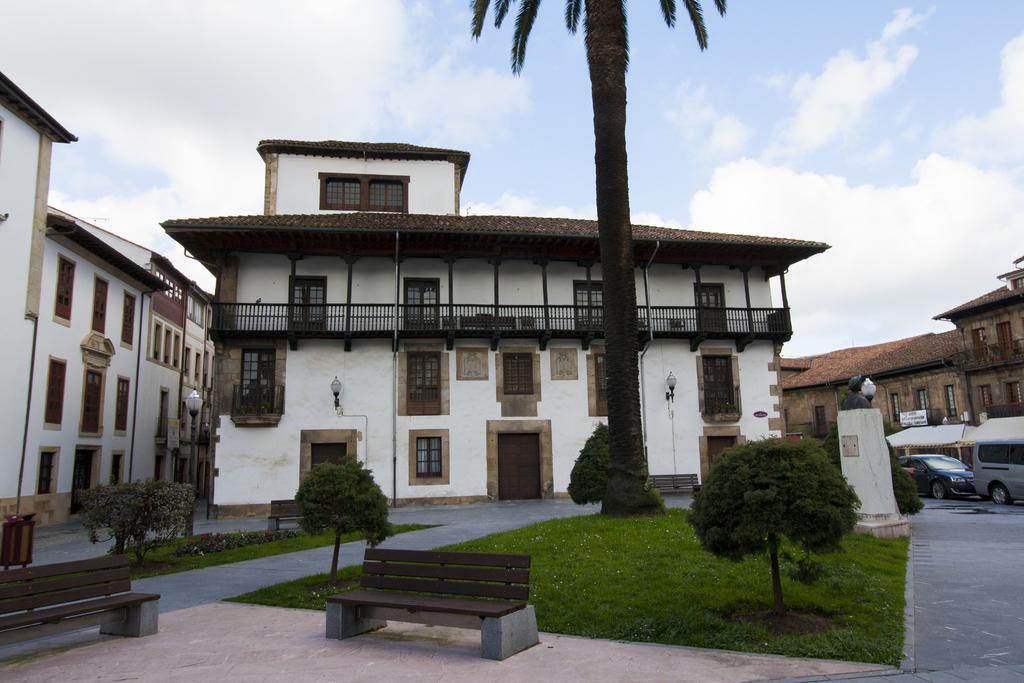How would you summarize this image in a sentence or two? At the top we can see sky with clouds. These are buildings. This is a door and window. Here we can see benches. We can see plants and grass. Here on the road we can see vehicles. 